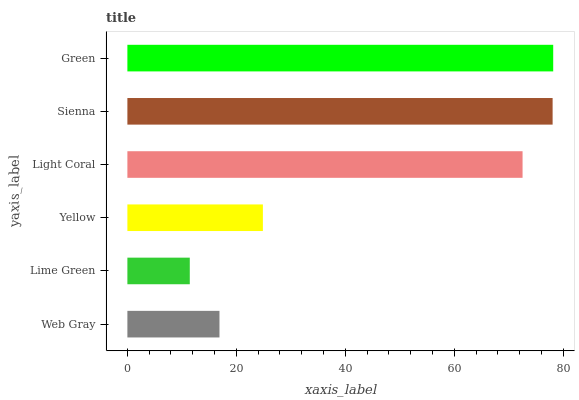Is Lime Green the minimum?
Answer yes or no. Yes. Is Green the maximum?
Answer yes or no. Yes. Is Yellow the minimum?
Answer yes or no. No. Is Yellow the maximum?
Answer yes or no. No. Is Yellow greater than Lime Green?
Answer yes or no. Yes. Is Lime Green less than Yellow?
Answer yes or no. Yes. Is Lime Green greater than Yellow?
Answer yes or no. No. Is Yellow less than Lime Green?
Answer yes or no. No. Is Light Coral the high median?
Answer yes or no. Yes. Is Yellow the low median?
Answer yes or no. Yes. Is Lime Green the high median?
Answer yes or no. No. Is Web Gray the low median?
Answer yes or no. No. 